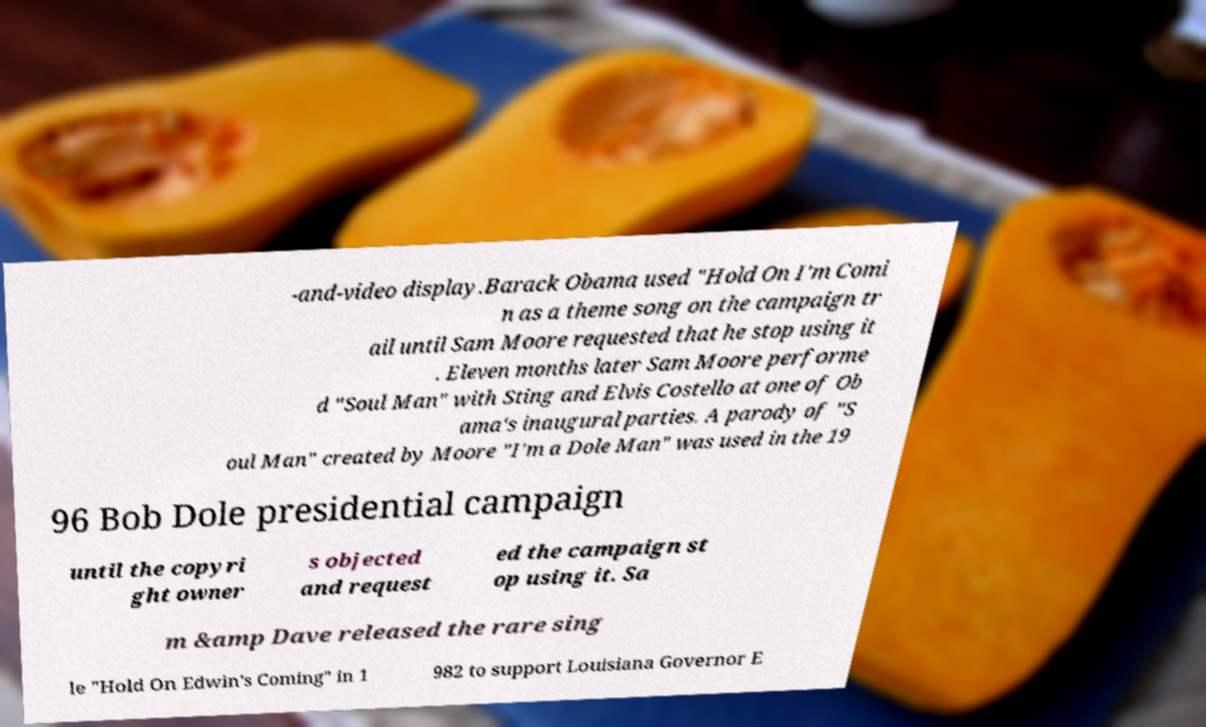Please identify and transcribe the text found in this image. -and-video display.Barack Obama used "Hold On I'm Comi n as a theme song on the campaign tr ail until Sam Moore requested that he stop using it . Eleven months later Sam Moore performe d "Soul Man" with Sting and Elvis Costello at one of Ob ama's inaugural parties. A parody of "S oul Man" created by Moore "I'm a Dole Man" was used in the 19 96 Bob Dole presidential campaign until the copyri ght owner s objected and request ed the campaign st op using it. Sa m &amp Dave released the rare sing le "Hold On Edwin's Coming" in 1 982 to support Louisiana Governor E 